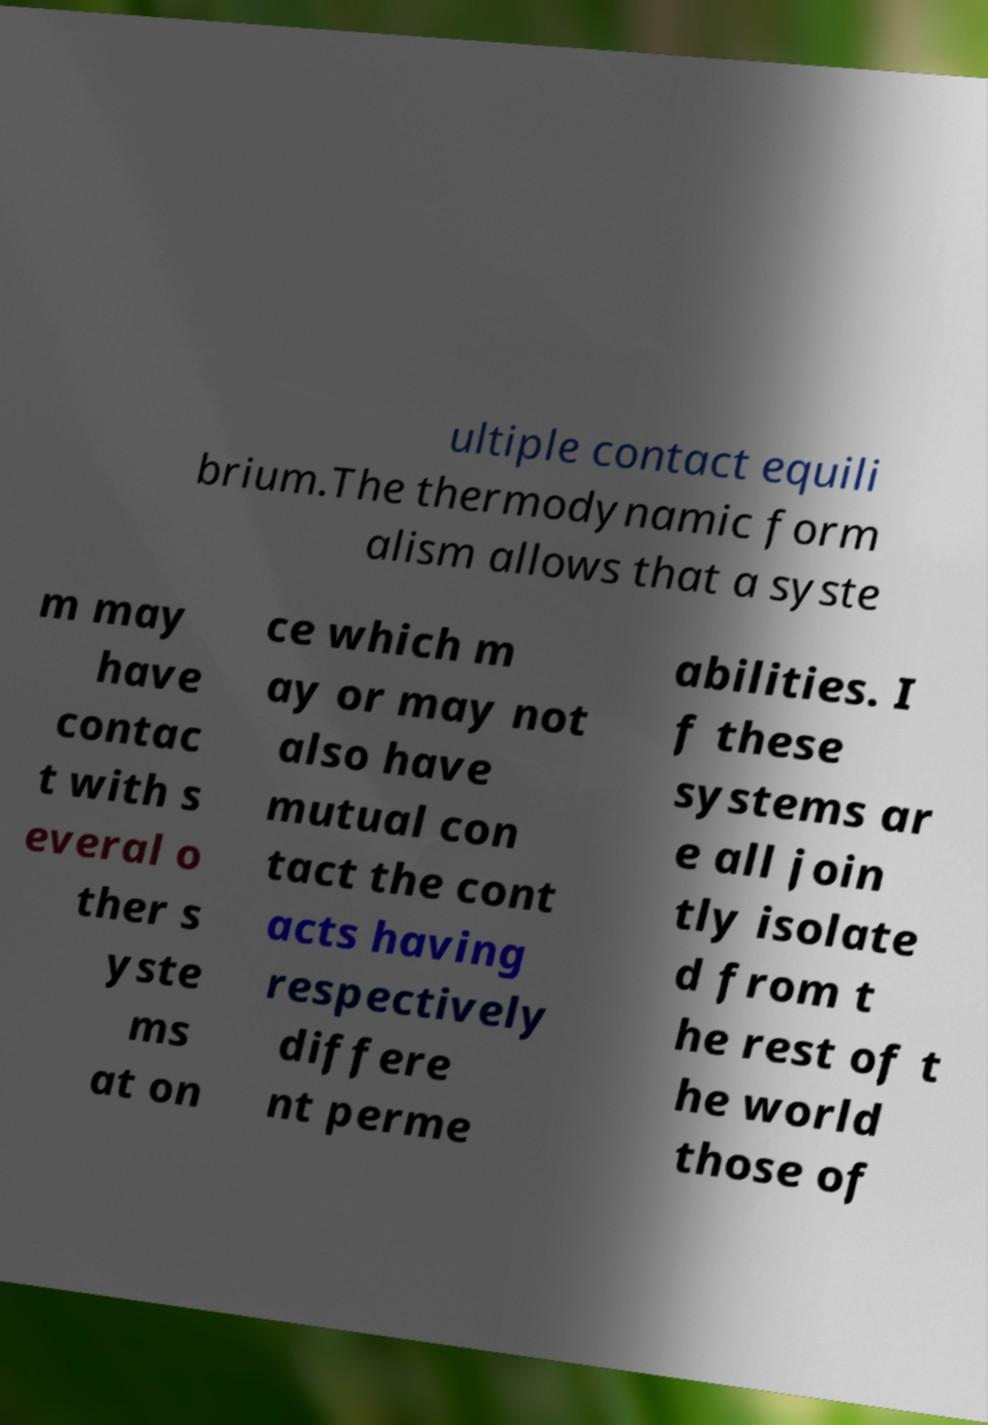Could you assist in decoding the text presented in this image and type it out clearly? ultiple contact equili brium.The thermodynamic form alism allows that a syste m may have contac t with s everal o ther s yste ms at on ce which m ay or may not also have mutual con tact the cont acts having respectively differe nt perme abilities. I f these systems ar e all join tly isolate d from t he rest of t he world those of 